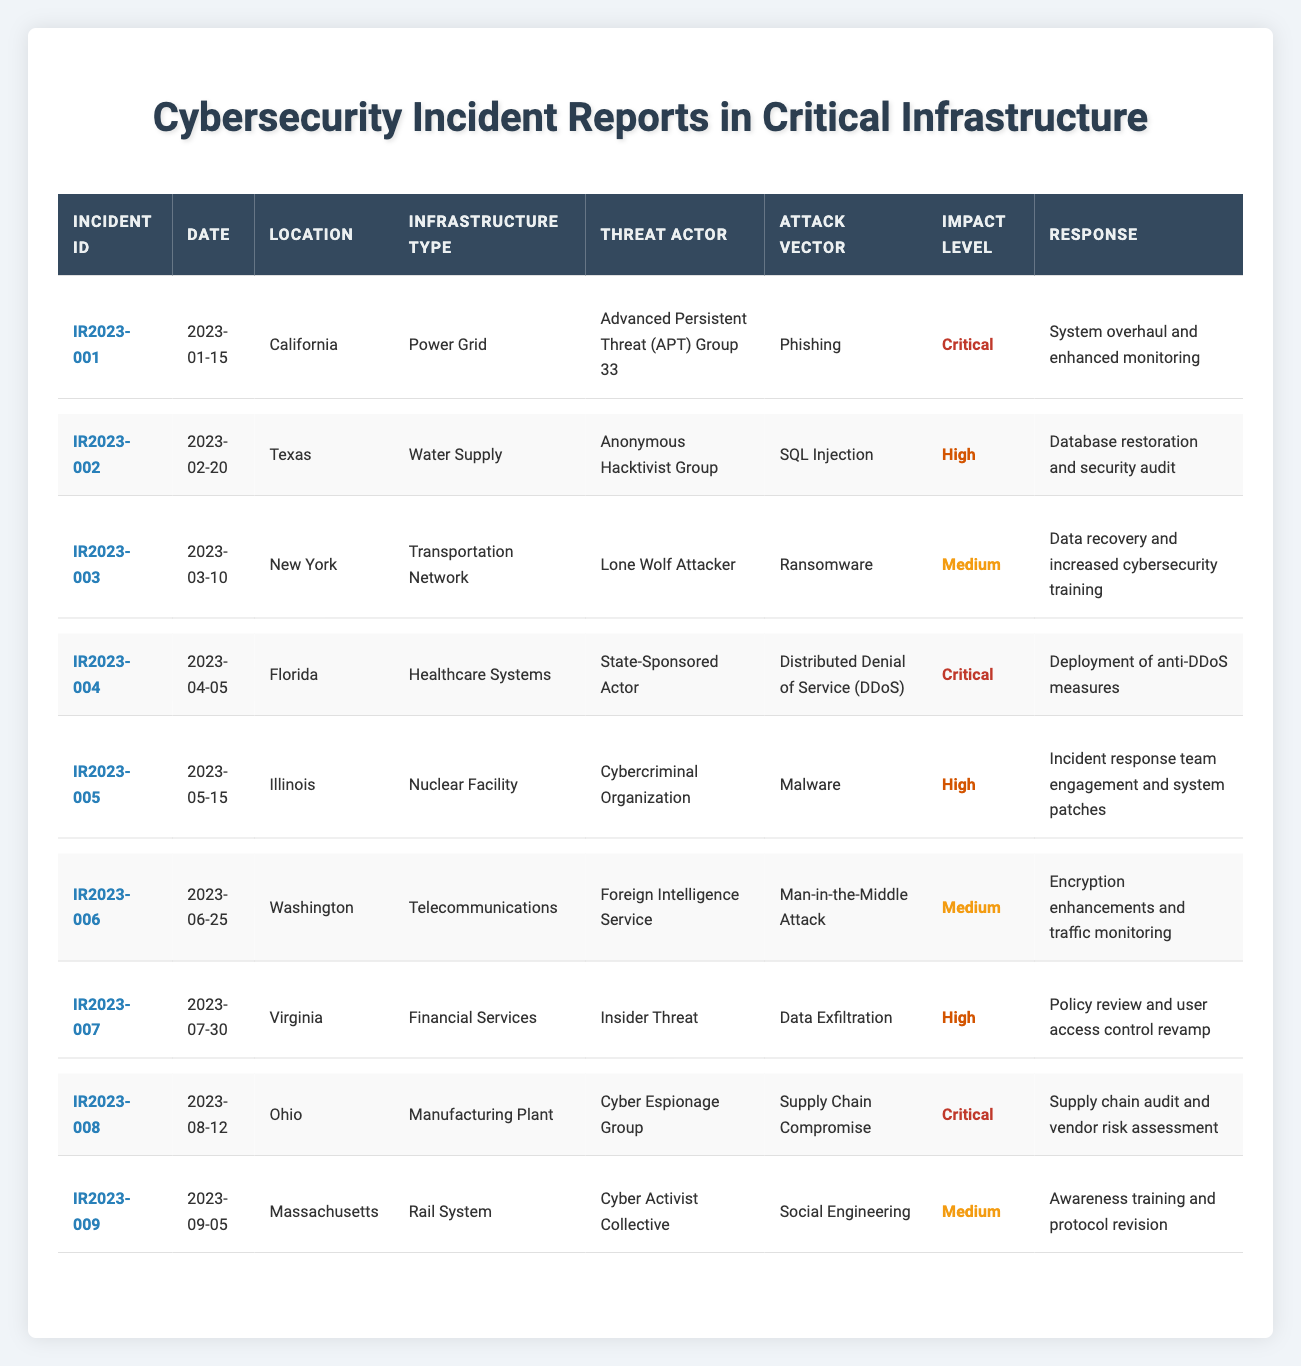What is the date of the incident report with ID IR2023-005? The table shows that the incident with ID IR2023-005 is dated 2023-05-15.
Answer: 2023-05-15 Which incident has the highest impact level? The table indicates that incidents with IDs IR2023-001, IR2023-004, and IR2023-008 all have a critical impact level, which is the highest.
Answer: IR2023-001, IR2023-004, IR2023-008 How many incidents occurred in the month of June? By reviewing the table, I see that there is one incident, IR2023-006, that occurred in June (2023-06-25).
Answer: 1 Is the incident in Ohio classified as high impact? The table shows that the incident in Ohio (IR2023-008) has a critical impact level, which is higher than high impact. Therefore, it’s not classified as high impact.
Answer: No Which attack vector was used by the Advanced Persistent Threat (APT) Group 33? According to the table, the attack vector used by the APT Group 33 in incident IR2023-001 is phishing.
Answer: Phishing What is the total number of critical impact incidents reported in the table? The table lists three incidents (IR2023-001, IR2023-004, IR2023-008) that are classified as critical impact.
Answer: 3 Which incident involved a Distributed Denial of Service attack? The table indicates that IR2023-004 involved a Distributed Denial of Service (DDoS) attack.
Answer: IR2023-004 Which infrastructure type had the incident with the earliest date? By comparing the dates in the table, the incident in California (IR2023-001) occurred first on 2023-01-15, making it the earliest.
Answer: Power Grid How many incidents in financial services have a high impact level? According to the table, there is one incident - IR2023-007, which has a high impact level in the financial services category.
Answer: 1 What is the most common attack vector listed in the incident reports? Evaluating the table, I find that phishing, SQL injection, ransomware, DDoS, malware, Man-in-the-Middle attack, data exfiltration, supply chain compromise, and social engineering are present; phishing appears once only. No attack vector is repeated.
Answer: No single attack vector is the most common 